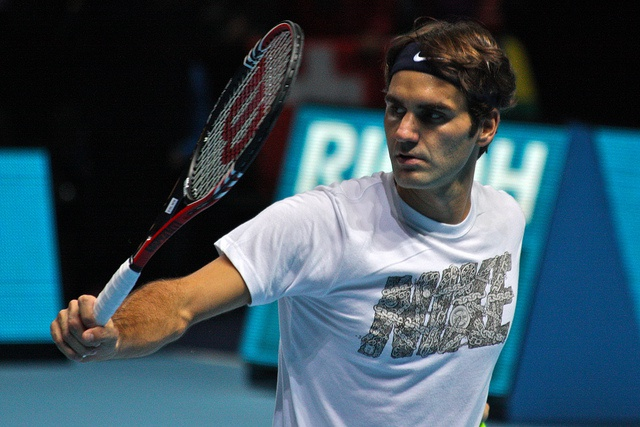Describe the objects in this image and their specific colors. I can see people in black, lightgray, darkgray, and gray tones and tennis racket in black, gray, and maroon tones in this image. 